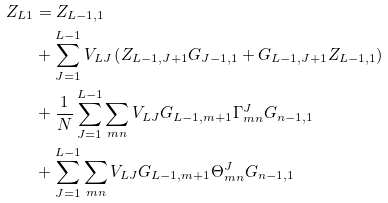<formula> <loc_0><loc_0><loc_500><loc_500>Z _ { L 1 } & = Z _ { L - 1 , 1 } \\ & + \sum _ { J = 1 } ^ { L - 1 } V _ { L J } \left ( Z _ { L - 1 , J + 1 } G _ { J - 1 , 1 } + G _ { L - 1 , J + 1 } Z _ { L - 1 , 1 } \right ) \\ & + \frac { 1 } { N } \sum _ { J = 1 } ^ { L - 1 } \sum _ { m n } V _ { L J } G _ { L - 1 , m + 1 } \Gamma _ { m n } ^ { J } G _ { n - 1 , 1 } \\ & + \sum _ { J = 1 } ^ { L - 1 } \sum _ { m n } V _ { L J } G _ { L - 1 , m + 1 } \Theta _ { m n } ^ { J } G _ { n - 1 , 1 }</formula> 